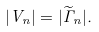<formula> <loc_0><loc_0><loc_500><loc_500>| V _ { n } | = | \widetilde { \Gamma } _ { n } | .</formula> 